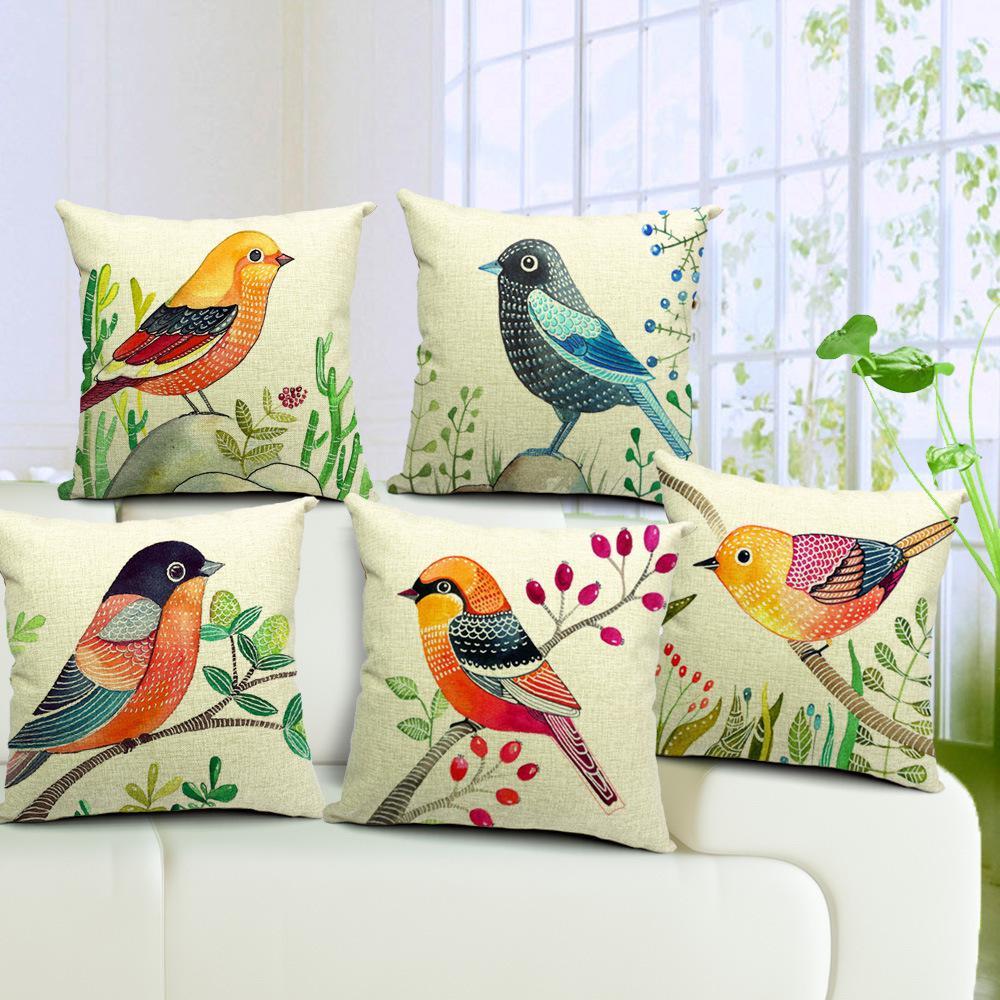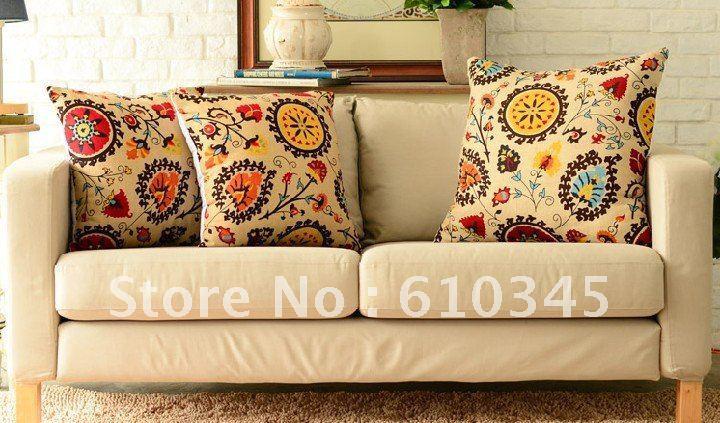The first image is the image on the left, the second image is the image on the right. Analyze the images presented: Is the assertion "All of the pillows in one image feature multicolored birds on branches and have a pale neutral background color." valid? Answer yes or no. Yes. The first image is the image on the left, the second image is the image on the right. Analyze the images presented: Is the assertion "The left image has exactly five pillows." valid? Answer yes or no. Yes. 